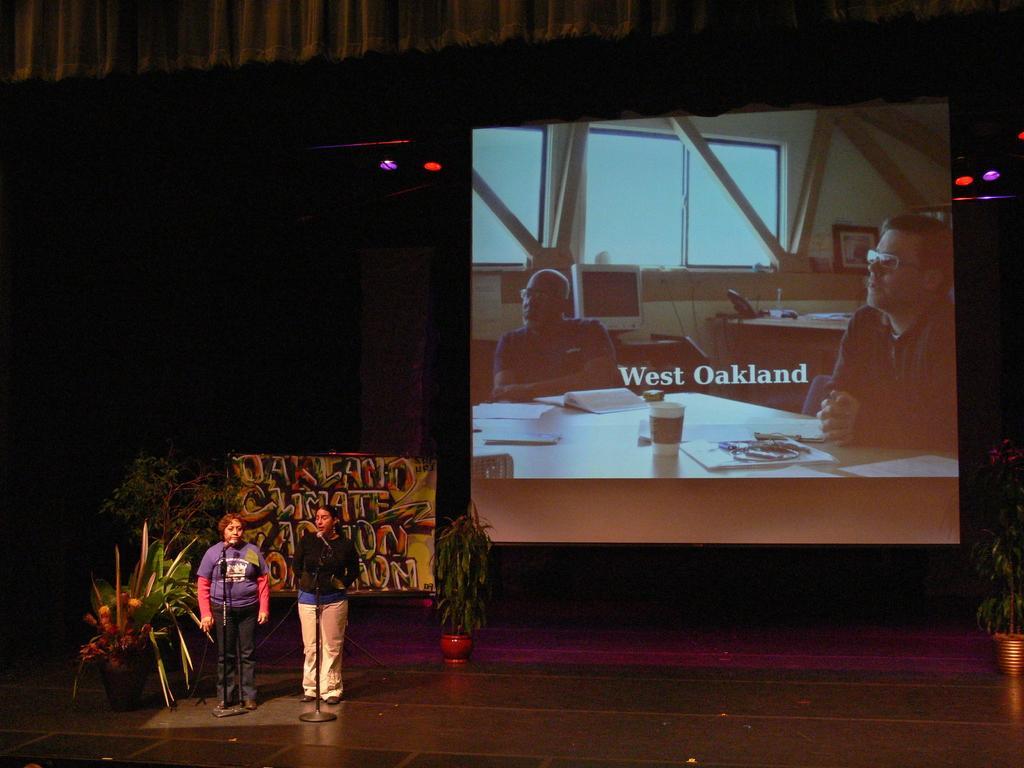In one or two sentences, can you explain what this image depicts? This image consists of two persons standing in front of mic stands. Behind them, there are plants and a board. On the right, we can see a screen. At the bottom, there is a dais. At the top, there is a curtain. 